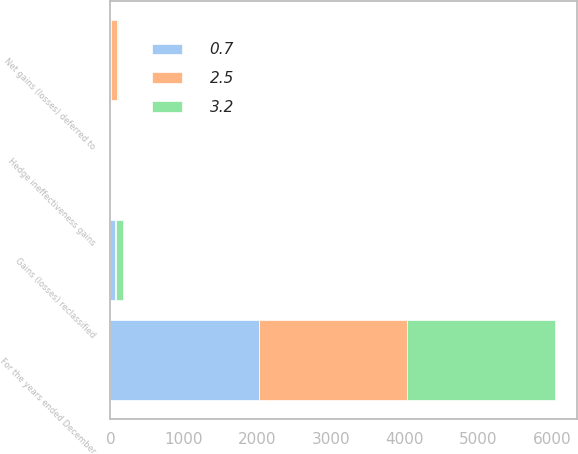Convert chart. <chart><loc_0><loc_0><loc_500><loc_500><stacked_bar_chart><ecel><fcel>For the years ended December<fcel>Net gains (losses) deferred to<fcel>Gains (losses) reclassified<fcel>Hedge ineffectiveness gains<nl><fcel>0.7<fcel>2014<fcel>11.2<fcel>68.5<fcel>2.5<nl><fcel>2.5<fcel>2013<fcel>84.7<fcel>8.4<fcel>3.2<nl><fcel>3.2<fcel>2012<fcel>12.8<fcel>90.9<fcel>0.7<nl></chart> 